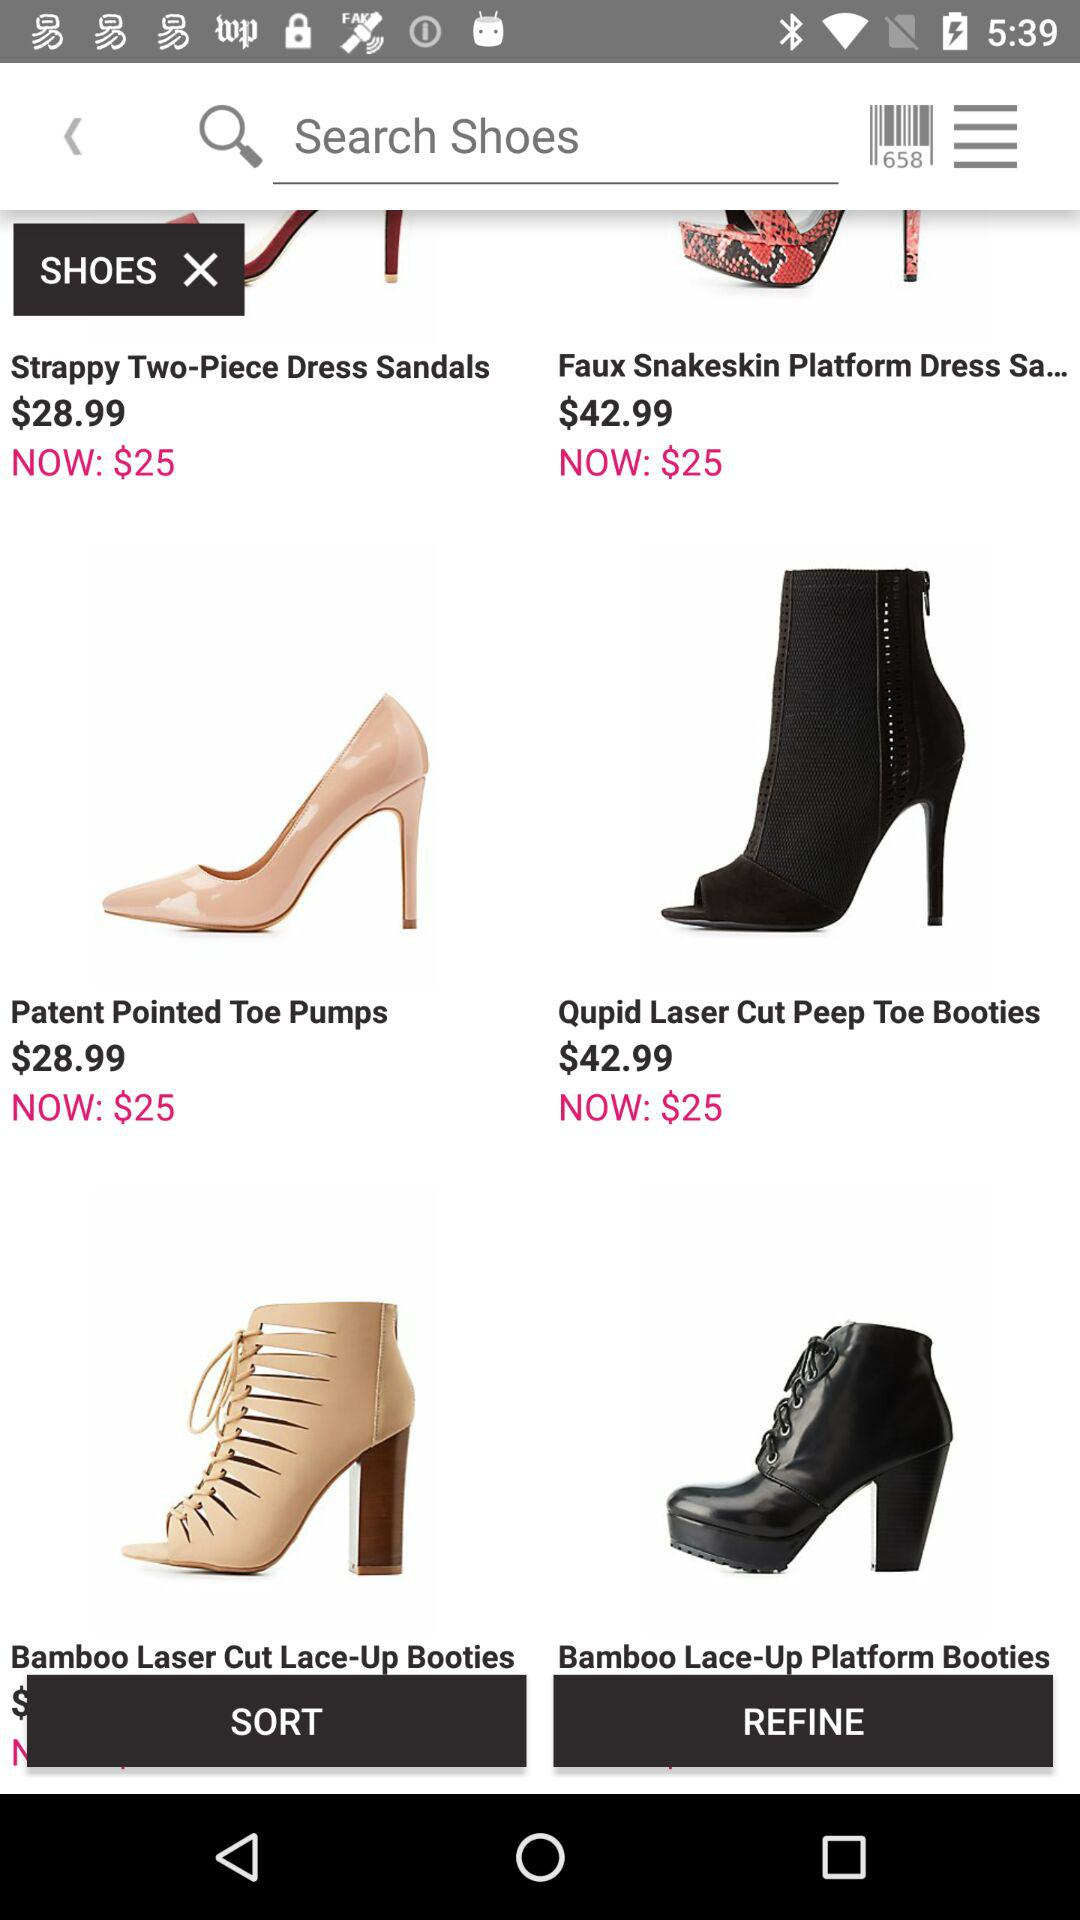What's the current price of the patent-pointed toe pumps? The current price is $25. 